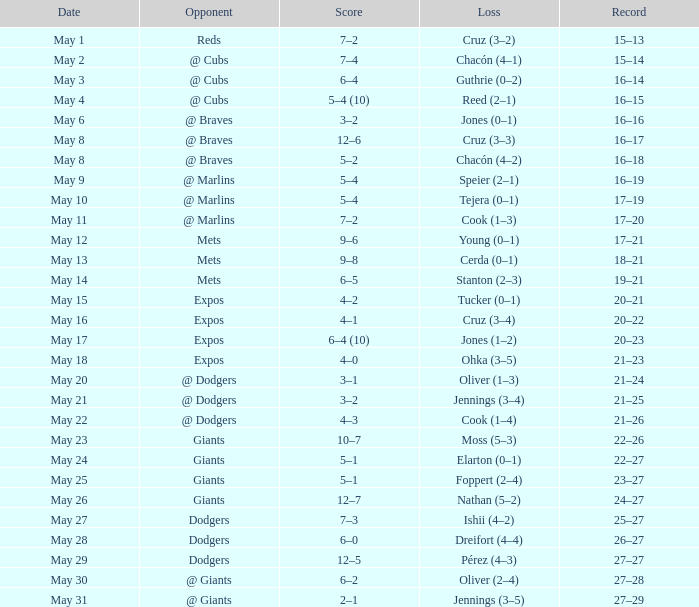Tell me who was the opponent on May 6 @ Braves. 